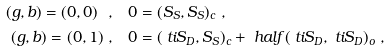Convert formula to latex. <formula><loc_0><loc_0><loc_500><loc_500>( g , b ) = ( 0 , 0 ) \ , & \quad 0 = ( S _ { S } , S _ { S } ) _ { c } \ , \\ ( g , b ) = ( 0 , 1 ) \ , & \quad 0 = ( \ t i { S } _ { D } , S _ { S } ) _ { c } + \ h a l f ( \ t i { S } _ { D } , \ t i { S } _ { D } ) _ { o } \ ,</formula> 